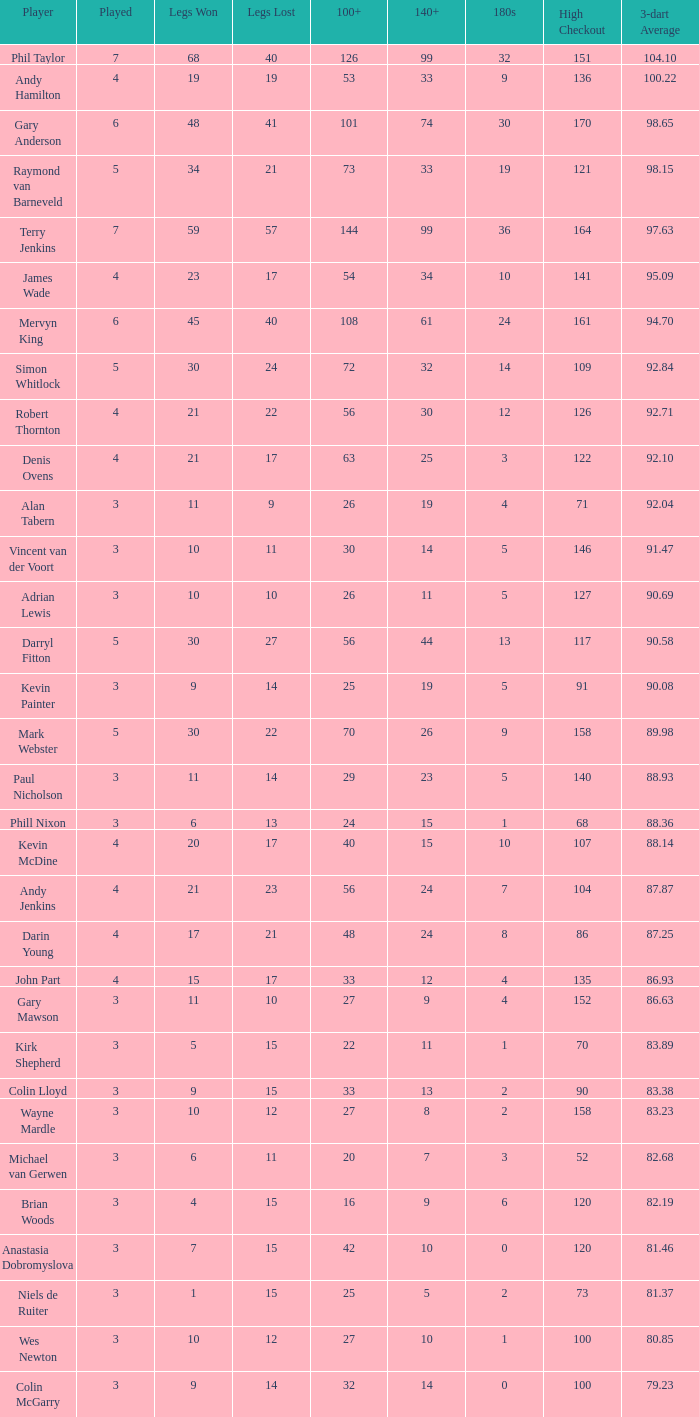What is the top legs lost with a 180s above 1, a 100+ of 53, and played is under 4? None. 